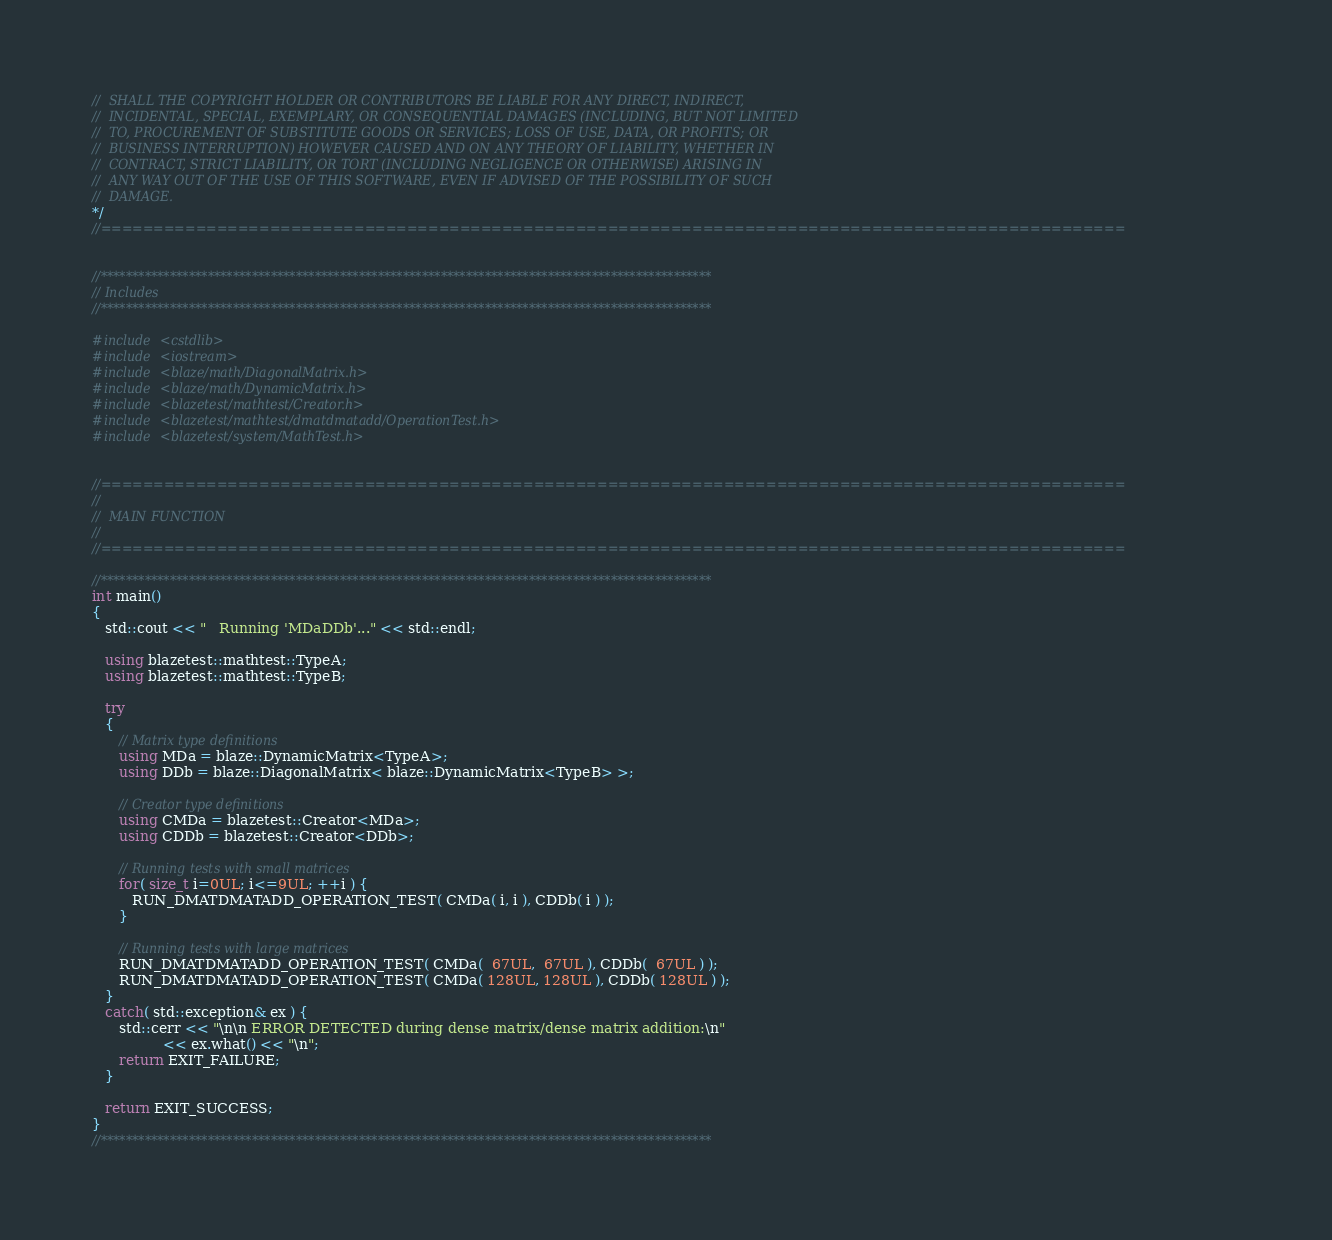<code> <loc_0><loc_0><loc_500><loc_500><_C++_>//  SHALL THE COPYRIGHT HOLDER OR CONTRIBUTORS BE LIABLE FOR ANY DIRECT, INDIRECT,
//  INCIDENTAL, SPECIAL, EXEMPLARY, OR CONSEQUENTIAL DAMAGES (INCLUDING, BUT NOT LIMITED
//  TO, PROCUREMENT OF SUBSTITUTE GOODS OR SERVICES; LOSS OF USE, DATA, OR PROFITS; OR
//  BUSINESS INTERRUPTION) HOWEVER CAUSED AND ON ANY THEORY OF LIABILITY, WHETHER IN
//  CONTRACT, STRICT LIABILITY, OR TORT (INCLUDING NEGLIGENCE OR OTHERWISE) ARISING IN
//  ANY WAY OUT OF THE USE OF THIS SOFTWARE, EVEN IF ADVISED OF THE POSSIBILITY OF SUCH
//  DAMAGE.
*/
//=================================================================================================


//*************************************************************************************************
// Includes
//*************************************************************************************************

#include <cstdlib>
#include <iostream>
#include <blaze/math/DiagonalMatrix.h>
#include <blaze/math/DynamicMatrix.h>
#include <blazetest/mathtest/Creator.h>
#include <blazetest/mathtest/dmatdmatadd/OperationTest.h>
#include <blazetest/system/MathTest.h>


//=================================================================================================
//
//  MAIN FUNCTION
//
//=================================================================================================

//*************************************************************************************************
int main()
{
   std::cout << "   Running 'MDaDDb'..." << std::endl;

   using blazetest::mathtest::TypeA;
   using blazetest::mathtest::TypeB;

   try
   {
      // Matrix type definitions
      using MDa = blaze::DynamicMatrix<TypeA>;
      using DDb = blaze::DiagonalMatrix< blaze::DynamicMatrix<TypeB> >;

      // Creator type definitions
      using CMDa = blazetest::Creator<MDa>;
      using CDDb = blazetest::Creator<DDb>;

      // Running tests with small matrices
      for( size_t i=0UL; i<=9UL; ++i ) {
         RUN_DMATDMATADD_OPERATION_TEST( CMDa( i, i ), CDDb( i ) );
      }

      // Running tests with large matrices
      RUN_DMATDMATADD_OPERATION_TEST( CMDa(  67UL,  67UL ), CDDb(  67UL ) );
      RUN_DMATDMATADD_OPERATION_TEST( CMDa( 128UL, 128UL ), CDDb( 128UL ) );
   }
   catch( std::exception& ex ) {
      std::cerr << "\n\n ERROR DETECTED during dense matrix/dense matrix addition:\n"
                << ex.what() << "\n";
      return EXIT_FAILURE;
   }

   return EXIT_SUCCESS;
}
//*************************************************************************************************
</code> 